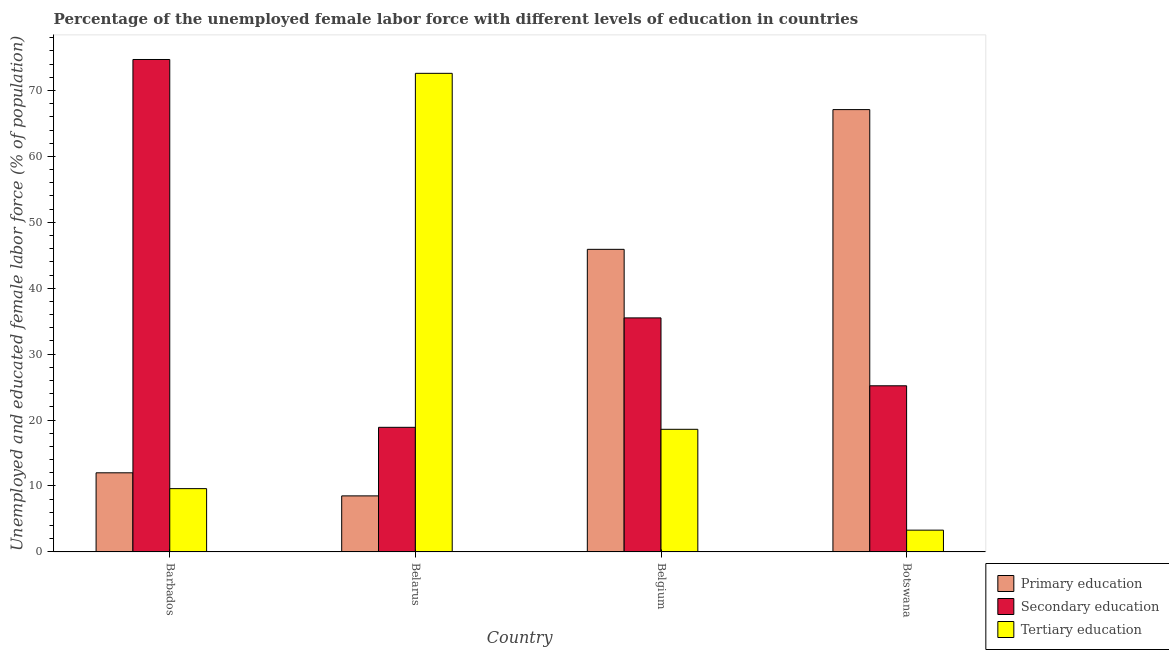How many different coloured bars are there?
Provide a short and direct response. 3. Are the number of bars per tick equal to the number of legend labels?
Make the answer very short. Yes. How many bars are there on the 1st tick from the right?
Provide a short and direct response. 3. What is the label of the 2nd group of bars from the left?
Offer a very short reply. Belarus. In how many cases, is the number of bars for a given country not equal to the number of legend labels?
Give a very brief answer. 0. What is the percentage of female labor force who received secondary education in Botswana?
Your answer should be very brief. 25.2. Across all countries, what is the maximum percentage of female labor force who received tertiary education?
Your response must be concise. 72.6. Across all countries, what is the minimum percentage of female labor force who received secondary education?
Ensure brevity in your answer.  18.9. In which country was the percentage of female labor force who received tertiary education maximum?
Make the answer very short. Belarus. In which country was the percentage of female labor force who received tertiary education minimum?
Give a very brief answer. Botswana. What is the total percentage of female labor force who received secondary education in the graph?
Provide a succinct answer. 154.3. What is the difference between the percentage of female labor force who received secondary education in Barbados and that in Belarus?
Provide a succinct answer. 55.8. What is the average percentage of female labor force who received secondary education per country?
Offer a terse response. 38.57. What is the difference between the percentage of female labor force who received secondary education and percentage of female labor force who received primary education in Belarus?
Ensure brevity in your answer.  10.4. What is the ratio of the percentage of female labor force who received secondary education in Belarus to that in Belgium?
Your answer should be compact. 0.53. What is the difference between the highest and the second highest percentage of female labor force who received primary education?
Make the answer very short. 21.2. What is the difference between the highest and the lowest percentage of female labor force who received tertiary education?
Offer a terse response. 69.3. Is the sum of the percentage of female labor force who received tertiary education in Barbados and Belgium greater than the maximum percentage of female labor force who received primary education across all countries?
Offer a terse response. No. What does the 3rd bar from the right in Barbados represents?
Offer a terse response. Primary education. How many countries are there in the graph?
Offer a terse response. 4. What is the difference between two consecutive major ticks on the Y-axis?
Keep it short and to the point. 10. Does the graph contain grids?
Make the answer very short. No. How many legend labels are there?
Give a very brief answer. 3. How are the legend labels stacked?
Provide a succinct answer. Vertical. What is the title of the graph?
Offer a very short reply. Percentage of the unemployed female labor force with different levels of education in countries. What is the label or title of the X-axis?
Offer a very short reply. Country. What is the label or title of the Y-axis?
Make the answer very short. Unemployed and educated female labor force (% of population). What is the Unemployed and educated female labor force (% of population) of Secondary education in Barbados?
Give a very brief answer. 74.7. What is the Unemployed and educated female labor force (% of population) in Tertiary education in Barbados?
Keep it short and to the point. 9.6. What is the Unemployed and educated female labor force (% of population) in Secondary education in Belarus?
Your answer should be very brief. 18.9. What is the Unemployed and educated female labor force (% of population) of Tertiary education in Belarus?
Your response must be concise. 72.6. What is the Unemployed and educated female labor force (% of population) of Primary education in Belgium?
Ensure brevity in your answer.  45.9. What is the Unemployed and educated female labor force (% of population) in Secondary education in Belgium?
Keep it short and to the point. 35.5. What is the Unemployed and educated female labor force (% of population) of Tertiary education in Belgium?
Give a very brief answer. 18.6. What is the Unemployed and educated female labor force (% of population) in Primary education in Botswana?
Your response must be concise. 67.1. What is the Unemployed and educated female labor force (% of population) of Secondary education in Botswana?
Offer a terse response. 25.2. What is the Unemployed and educated female labor force (% of population) of Tertiary education in Botswana?
Your response must be concise. 3.3. Across all countries, what is the maximum Unemployed and educated female labor force (% of population) of Primary education?
Offer a terse response. 67.1. Across all countries, what is the maximum Unemployed and educated female labor force (% of population) of Secondary education?
Offer a terse response. 74.7. Across all countries, what is the maximum Unemployed and educated female labor force (% of population) in Tertiary education?
Provide a short and direct response. 72.6. Across all countries, what is the minimum Unemployed and educated female labor force (% of population) of Primary education?
Offer a very short reply. 8.5. Across all countries, what is the minimum Unemployed and educated female labor force (% of population) in Secondary education?
Ensure brevity in your answer.  18.9. Across all countries, what is the minimum Unemployed and educated female labor force (% of population) in Tertiary education?
Offer a terse response. 3.3. What is the total Unemployed and educated female labor force (% of population) in Primary education in the graph?
Your answer should be compact. 133.5. What is the total Unemployed and educated female labor force (% of population) in Secondary education in the graph?
Give a very brief answer. 154.3. What is the total Unemployed and educated female labor force (% of population) in Tertiary education in the graph?
Your response must be concise. 104.1. What is the difference between the Unemployed and educated female labor force (% of population) in Primary education in Barbados and that in Belarus?
Keep it short and to the point. 3.5. What is the difference between the Unemployed and educated female labor force (% of population) of Secondary education in Barbados and that in Belarus?
Offer a terse response. 55.8. What is the difference between the Unemployed and educated female labor force (% of population) of Tertiary education in Barbados and that in Belarus?
Ensure brevity in your answer.  -63. What is the difference between the Unemployed and educated female labor force (% of population) of Primary education in Barbados and that in Belgium?
Give a very brief answer. -33.9. What is the difference between the Unemployed and educated female labor force (% of population) of Secondary education in Barbados and that in Belgium?
Your response must be concise. 39.2. What is the difference between the Unemployed and educated female labor force (% of population) in Primary education in Barbados and that in Botswana?
Provide a succinct answer. -55.1. What is the difference between the Unemployed and educated female labor force (% of population) of Secondary education in Barbados and that in Botswana?
Your answer should be compact. 49.5. What is the difference between the Unemployed and educated female labor force (% of population) of Tertiary education in Barbados and that in Botswana?
Provide a succinct answer. 6.3. What is the difference between the Unemployed and educated female labor force (% of population) of Primary education in Belarus and that in Belgium?
Your answer should be very brief. -37.4. What is the difference between the Unemployed and educated female labor force (% of population) in Secondary education in Belarus and that in Belgium?
Keep it short and to the point. -16.6. What is the difference between the Unemployed and educated female labor force (% of population) of Tertiary education in Belarus and that in Belgium?
Offer a very short reply. 54. What is the difference between the Unemployed and educated female labor force (% of population) in Primary education in Belarus and that in Botswana?
Your answer should be very brief. -58.6. What is the difference between the Unemployed and educated female labor force (% of population) of Secondary education in Belarus and that in Botswana?
Offer a very short reply. -6.3. What is the difference between the Unemployed and educated female labor force (% of population) in Tertiary education in Belarus and that in Botswana?
Offer a terse response. 69.3. What is the difference between the Unemployed and educated female labor force (% of population) of Primary education in Belgium and that in Botswana?
Ensure brevity in your answer.  -21.2. What is the difference between the Unemployed and educated female labor force (% of population) of Secondary education in Belgium and that in Botswana?
Keep it short and to the point. 10.3. What is the difference between the Unemployed and educated female labor force (% of population) of Tertiary education in Belgium and that in Botswana?
Keep it short and to the point. 15.3. What is the difference between the Unemployed and educated female labor force (% of population) in Primary education in Barbados and the Unemployed and educated female labor force (% of population) in Secondary education in Belarus?
Your answer should be compact. -6.9. What is the difference between the Unemployed and educated female labor force (% of population) of Primary education in Barbados and the Unemployed and educated female labor force (% of population) of Tertiary education in Belarus?
Offer a terse response. -60.6. What is the difference between the Unemployed and educated female labor force (% of population) of Primary education in Barbados and the Unemployed and educated female labor force (% of population) of Secondary education in Belgium?
Your response must be concise. -23.5. What is the difference between the Unemployed and educated female labor force (% of population) in Secondary education in Barbados and the Unemployed and educated female labor force (% of population) in Tertiary education in Belgium?
Offer a terse response. 56.1. What is the difference between the Unemployed and educated female labor force (% of population) of Primary education in Barbados and the Unemployed and educated female labor force (% of population) of Secondary education in Botswana?
Your answer should be very brief. -13.2. What is the difference between the Unemployed and educated female labor force (% of population) of Secondary education in Barbados and the Unemployed and educated female labor force (% of population) of Tertiary education in Botswana?
Offer a very short reply. 71.4. What is the difference between the Unemployed and educated female labor force (% of population) of Primary education in Belarus and the Unemployed and educated female labor force (% of population) of Secondary education in Belgium?
Offer a very short reply. -27. What is the difference between the Unemployed and educated female labor force (% of population) in Primary education in Belarus and the Unemployed and educated female labor force (% of population) in Tertiary education in Belgium?
Your answer should be compact. -10.1. What is the difference between the Unemployed and educated female labor force (% of population) of Secondary education in Belarus and the Unemployed and educated female labor force (% of population) of Tertiary education in Belgium?
Your response must be concise. 0.3. What is the difference between the Unemployed and educated female labor force (% of population) in Primary education in Belarus and the Unemployed and educated female labor force (% of population) in Secondary education in Botswana?
Your answer should be very brief. -16.7. What is the difference between the Unemployed and educated female labor force (% of population) in Primary education in Belarus and the Unemployed and educated female labor force (% of population) in Tertiary education in Botswana?
Give a very brief answer. 5.2. What is the difference between the Unemployed and educated female labor force (% of population) of Primary education in Belgium and the Unemployed and educated female labor force (% of population) of Secondary education in Botswana?
Your answer should be compact. 20.7. What is the difference between the Unemployed and educated female labor force (% of population) of Primary education in Belgium and the Unemployed and educated female labor force (% of population) of Tertiary education in Botswana?
Provide a short and direct response. 42.6. What is the difference between the Unemployed and educated female labor force (% of population) in Secondary education in Belgium and the Unemployed and educated female labor force (% of population) in Tertiary education in Botswana?
Your response must be concise. 32.2. What is the average Unemployed and educated female labor force (% of population) of Primary education per country?
Ensure brevity in your answer.  33.38. What is the average Unemployed and educated female labor force (% of population) of Secondary education per country?
Ensure brevity in your answer.  38.58. What is the average Unemployed and educated female labor force (% of population) in Tertiary education per country?
Your answer should be very brief. 26.02. What is the difference between the Unemployed and educated female labor force (% of population) of Primary education and Unemployed and educated female labor force (% of population) of Secondary education in Barbados?
Give a very brief answer. -62.7. What is the difference between the Unemployed and educated female labor force (% of population) of Primary education and Unemployed and educated female labor force (% of population) of Tertiary education in Barbados?
Ensure brevity in your answer.  2.4. What is the difference between the Unemployed and educated female labor force (% of population) in Secondary education and Unemployed and educated female labor force (% of population) in Tertiary education in Barbados?
Offer a very short reply. 65.1. What is the difference between the Unemployed and educated female labor force (% of population) in Primary education and Unemployed and educated female labor force (% of population) in Tertiary education in Belarus?
Offer a very short reply. -64.1. What is the difference between the Unemployed and educated female labor force (% of population) in Secondary education and Unemployed and educated female labor force (% of population) in Tertiary education in Belarus?
Provide a succinct answer. -53.7. What is the difference between the Unemployed and educated female labor force (% of population) in Primary education and Unemployed and educated female labor force (% of population) in Tertiary education in Belgium?
Offer a very short reply. 27.3. What is the difference between the Unemployed and educated female labor force (% of population) of Primary education and Unemployed and educated female labor force (% of population) of Secondary education in Botswana?
Offer a terse response. 41.9. What is the difference between the Unemployed and educated female labor force (% of population) in Primary education and Unemployed and educated female labor force (% of population) in Tertiary education in Botswana?
Offer a terse response. 63.8. What is the difference between the Unemployed and educated female labor force (% of population) in Secondary education and Unemployed and educated female labor force (% of population) in Tertiary education in Botswana?
Provide a short and direct response. 21.9. What is the ratio of the Unemployed and educated female labor force (% of population) in Primary education in Barbados to that in Belarus?
Provide a short and direct response. 1.41. What is the ratio of the Unemployed and educated female labor force (% of population) in Secondary education in Barbados to that in Belarus?
Provide a succinct answer. 3.95. What is the ratio of the Unemployed and educated female labor force (% of population) in Tertiary education in Barbados to that in Belarus?
Your answer should be compact. 0.13. What is the ratio of the Unemployed and educated female labor force (% of population) in Primary education in Barbados to that in Belgium?
Offer a very short reply. 0.26. What is the ratio of the Unemployed and educated female labor force (% of population) of Secondary education in Barbados to that in Belgium?
Your response must be concise. 2.1. What is the ratio of the Unemployed and educated female labor force (% of population) of Tertiary education in Barbados to that in Belgium?
Provide a succinct answer. 0.52. What is the ratio of the Unemployed and educated female labor force (% of population) of Primary education in Barbados to that in Botswana?
Provide a short and direct response. 0.18. What is the ratio of the Unemployed and educated female labor force (% of population) in Secondary education in Barbados to that in Botswana?
Make the answer very short. 2.96. What is the ratio of the Unemployed and educated female labor force (% of population) in Tertiary education in Barbados to that in Botswana?
Your response must be concise. 2.91. What is the ratio of the Unemployed and educated female labor force (% of population) in Primary education in Belarus to that in Belgium?
Your answer should be compact. 0.19. What is the ratio of the Unemployed and educated female labor force (% of population) of Secondary education in Belarus to that in Belgium?
Keep it short and to the point. 0.53. What is the ratio of the Unemployed and educated female labor force (% of population) of Tertiary education in Belarus to that in Belgium?
Your response must be concise. 3.9. What is the ratio of the Unemployed and educated female labor force (% of population) in Primary education in Belarus to that in Botswana?
Offer a terse response. 0.13. What is the ratio of the Unemployed and educated female labor force (% of population) of Secondary education in Belarus to that in Botswana?
Provide a succinct answer. 0.75. What is the ratio of the Unemployed and educated female labor force (% of population) of Primary education in Belgium to that in Botswana?
Keep it short and to the point. 0.68. What is the ratio of the Unemployed and educated female labor force (% of population) of Secondary education in Belgium to that in Botswana?
Your answer should be compact. 1.41. What is the ratio of the Unemployed and educated female labor force (% of population) in Tertiary education in Belgium to that in Botswana?
Provide a short and direct response. 5.64. What is the difference between the highest and the second highest Unemployed and educated female labor force (% of population) of Primary education?
Give a very brief answer. 21.2. What is the difference between the highest and the second highest Unemployed and educated female labor force (% of population) of Secondary education?
Offer a very short reply. 39.2. What is the difference between the highest and the second highest Unemployed and educated female labor force (% of population) of Tertiary education?
Ensure brevity in your answer.  54. What is the difference between the highest and the lowest Unemployed and educated female labor force (% of population) of Primary education?
Your answer should be compact. 58.6. What is the difference between the highest and the lowest Unemployed and educated female labor force (% of population) in Secondary education?
Provide a short and direct response. 55.8. What is the difference between the highest and the lowest Unemployed and educated female labor force (% of population) in Tertiary education?
Make the answer very short. 69.3. 